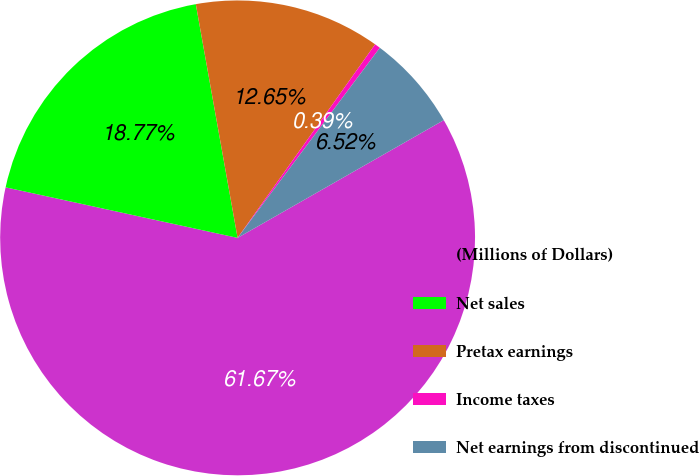Convert chart. <chart><loc_0><loc_0><loc_500><loc_500><pie_chart><fcel>(Millions of Dollars)<fcel>Net sales<fcel>Pretax earnings<fcel>Income taxes<fcel>Net earnings from discontinued<nl><fcel>61.67%<fcel>18.77%<fcel>12.65%<fcel>0.39%<fcel>6.52%<nl></chart> 